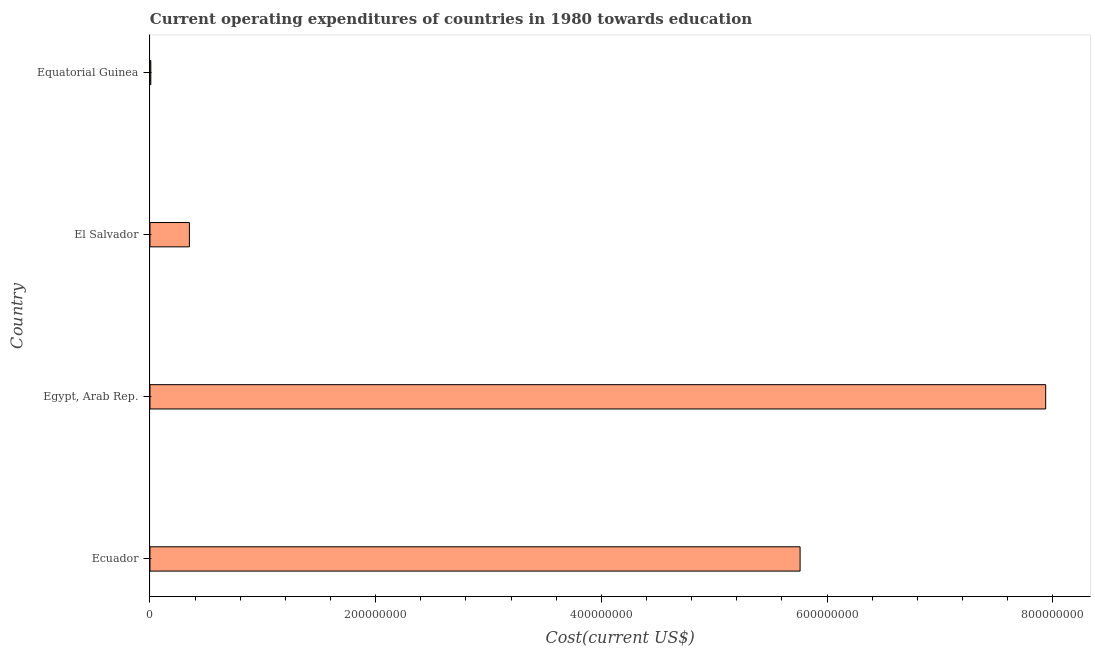Does the graph contain grids?
Make the answer very short. No. What is the title of the graph?
Offer a terse response. Current operating expenditures of countries in 1980 towards education. What is the label or title of the X-axis?
Give a very brief answer. Cost(current US$). What is the label or title of the Y-axis?
Your response must be concise. Country. What is the education expenditure in Egypt, Arab Rep.?
Your response must be concise. 7.94e+08. Across all countries, what is the maximum education expenditure?
Provide a succinct answer. 7.94e+08. Across all countries, what is the minimum education expenditure?
Make the answer very short. 7.32e+05. In which country was the education expenditure maximum?
Provide a succinct answer. Egypt, Arab Rep. In which country was the education expenditure minimum?
Your answer should be very brief. Equatorial Guinea. What is the sum of the education expenditure?
Provide a succinct answer. 1.41e+09. What is the difference between the education expenditure in Ecuador and Egypt, Arab Rep.?
Ensure brevity in your answer.  -2.18e+08. What is the average education expenditure per country?
Provide a short and direct response. 3.51e+08. What is the median education expenditure?
Give a very brief answer. 3.06e+08. In how many countries, is the education expenditure greater than 520000000 US$?
Offer a very short reply. 2. What is the ratio of the education expenditure in Ecuador to that in Equatorial Guinea?
Your answer should be compact. 787.03. What is the difference between the highest and the second highest education expenditure?
Your response must be concise. 2.18e+08. What is the difference between the highest and the lowest education expenditure?
Provide a succinct answer. 7.93e+08. Are all the bars in the graph horizontal?
Your response must be concise. Yes. What is the difference between two consecutive major ticks on the X-axis?
Your response must be concise. 2.00e+08. Are the values on the major ticks of X-axis written in scientific E-notation?
Ensure brevity in your answer.  No. What is the Cost(current US$) of Ecuador?
Make the answer very short. 5.76e+08. What is the Cost(current US$) of Egypt, Arab Rep.?
Ensure brevity in your answer.  7.94e+08. What is the Cost(current US$) of El Salvador?
Offer a very short reply. 3.49e+07. What is the Cost(current US$) of Equatorial Guinea?
Ensure brevity in your answer.  7.32e+05. What is the difference between the Cost(current US$) in Ecuador and Egypt, Arab Rep.?
Provide a short and direct response. -2.18e+08. What is the difference between the Cost(current US$) in Ecuador and El Salvador?
Make the answer very short. 5.41e+08. What is the difference between the Cost(current US$) in Ecuador and Equatorial Guinea?
Make the answer very short. 5.75e+08. What is the difference between the Cost(current US$) in Egypt, Arab Rep. and El Salvador?
Offer a very short reply. 7.59e+08. What is the difference between the Cost(current US$) in Egypt, Arab Rep. and Equatorial Guinea?
Give a very brief answer. 7.93e+08. What is the difference between the Cost(current US$) in El Salvador and Equatorial Guinea?
Your response must be concise. 3.42e+07. What is the ratio of the Cost(current US$) in Ecuador to that in Egypt, Arab Rep.?
Your answer should be very brief. 0.73. What is the ratio of the Cost(current US$) in Ecuador to that in El Salvador?
Ensure brevity in your answer.  16.51. What is the ratio of the Cost(current US$) in Ecuador to that in Equatorial Guinea?
Provide a short and direct response. 787.03. What is the ratio of the Cost(current US$) in Egypt, Arab Rep. to that in El Salvador?
Ensure brevity in your answer.  22.74. What is the ratio of the Cost(current US$) in Egypt, Arab Rep. to that in Equatorial Guinea?
Your answer should be very brief. 1084.36. What is the ratio of the Cost(current US$) in El Salvador to that in Equatorial Guinea?
Keep it short and to the point. 47.68. 